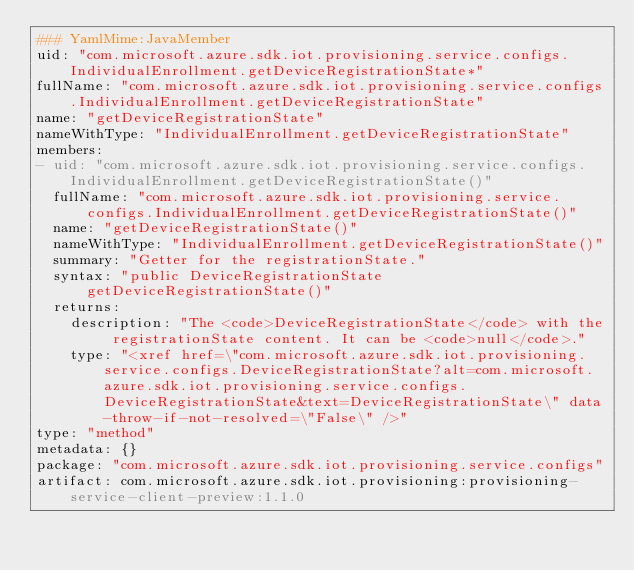Convert code to text. <code><loc_0><loc_0><loc_500><loc_500><_YAML_>### YamlMime:JavaMember
uid: "com.microsoft.azure.sdk.iot.provisioning.service.configs.IndividualEnrollment.getDeviceRegistrationState*"
fullName: "com.microsoft.azure.sdk.iot.provisioning.service.configs.IndividualEnrollment.getDeviceRegistrationState"
name: "getDeviceRegistrationState"
nameWithType: "IndividualEnrollment.getDeviceRegistrationState"
members:
- uid: "com.microsoft.azure.sdk.iot.provisioning.service.configs.IndividualEnrollment.getDeviceRegistrationState()"
  fullName: "com.microsoft.azure.sdk.iot.provisioning.service.configs.IndividualEnrollment.getDeviceRegistrationState()"
  name: "getDeviceRegistrationState()"
  nameWithType: "IndividualEnrollment.getDeviceRegistrationState()"
  summary: "Getter for the registrationState."
  syntax: "public DeviceRegistrationState getDeviceRegistrationState()"
  returns:
    description: "The <code>DeviceRegistrationState</code> with the registrationState content. It can be <code>null</code>."
    type: "<xref href=\"com.microsoft.azure.sdk.iot.provisioning.service.configs.DeviceRegistrationState?alt=com.microsoft.azure.sdk.iot.provisioning.service.configs.DeviceRegistrationState&text=DeviceRegistrationState\" data-throw-if-not-resolved=\"False\" />"
type: "method"
metadata: {}
package: "com.microsoft.azure.sdk.iot.provisioning.service.configs"
artifact: com.microsoft.azure.sdk.iot.provisioning:provisioning-service-client-preview:1.1.0
</code> 